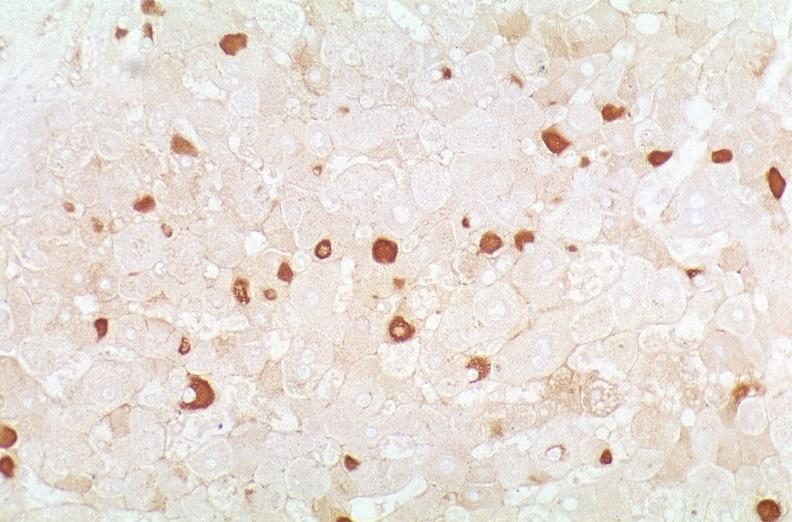what is present?
Answer the question using a single word or phrase. Hepatobiliary 